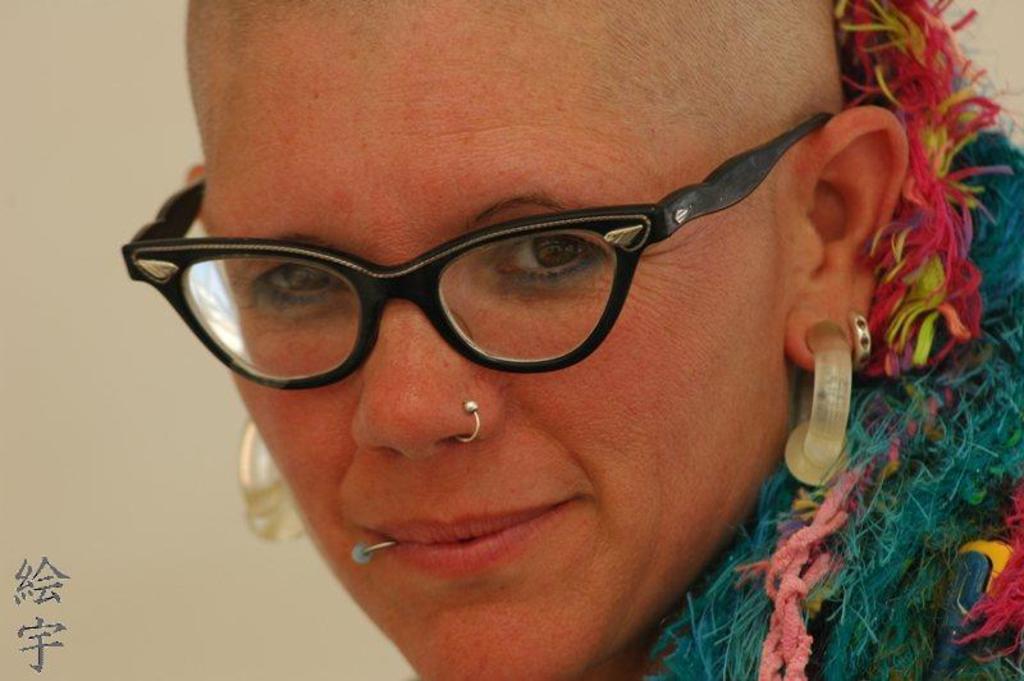In one or two sentences, can you explain what this image depicts? In this picture there is a woman who is wearing spectacle, earring and blue dress. She is smiling. Beside her there is a wall. At the bottom left corner there is a watermark. 